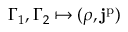<formula> <loc_0><loc_0><loc_500><loc_500>\Gamma _ { 1 } , \Gamma _ { 2 } \mapsto ( \rho , j ^ { p } )</formula> 